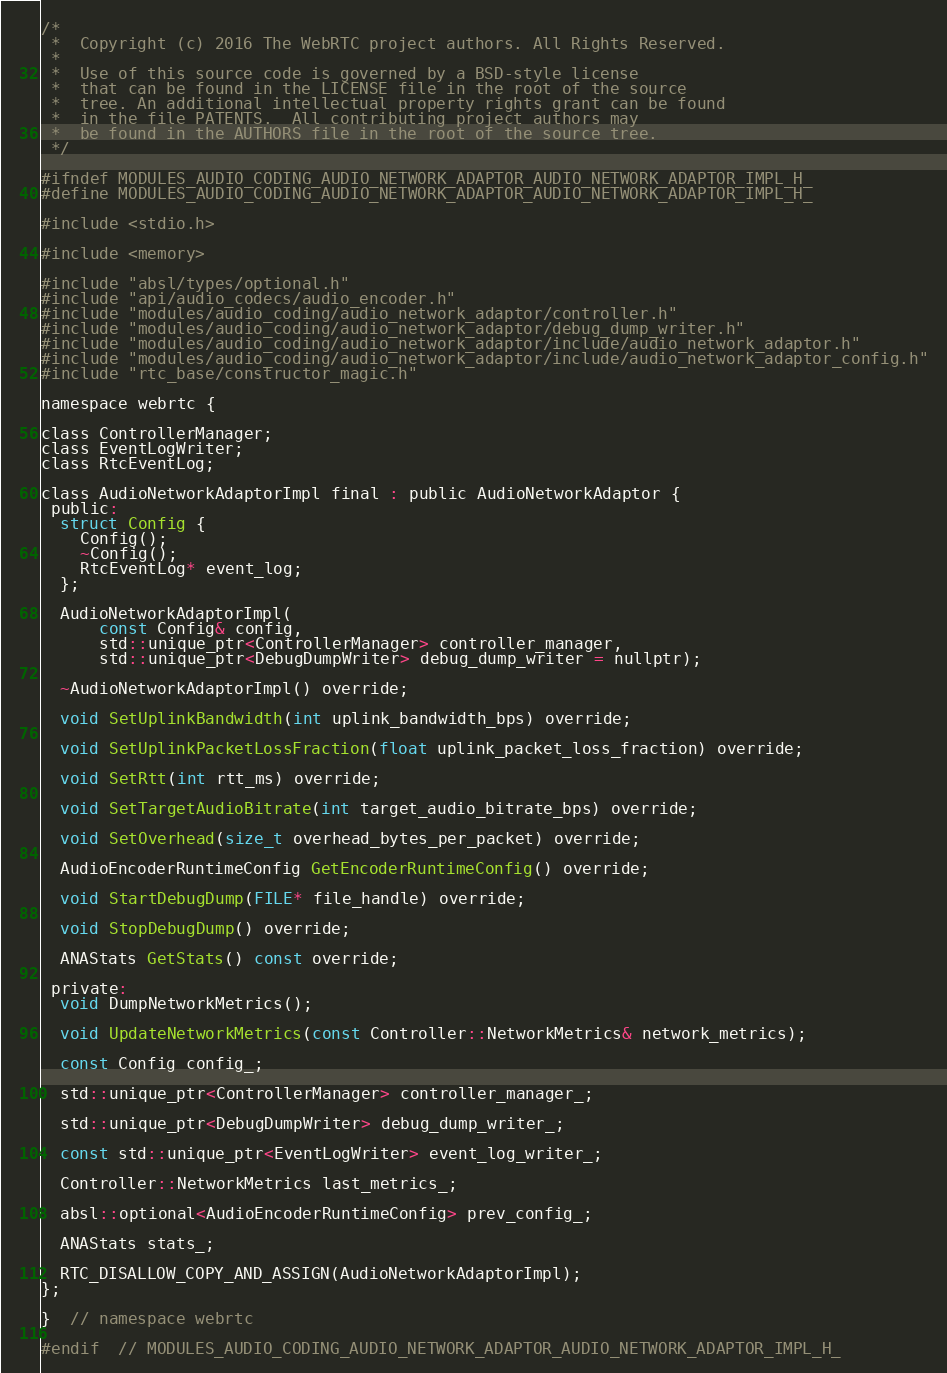<code> <loc_0><loc_0><loc_500><loc_500><_C_>/*
 *  Copyright (c) 2016 The WebRTC project authors. All Rights Reserved.
 *
 *  Use of this source code is governed by a BSD-style license
 *  that can be found in the LICENSE file in the root of the source
 *  tree. An additional intellectual property rights grant can be found
 *  in the file PATENTS.  All contributing project authors may
 *  be found in the AUTHORS file in the root of the source tree.
 */

#ifndef MODULES_AUDIO_CODING_AUDIO_NETWORK_ADAPTOR_AUDIO_NETWORK_ADAPTOR_IMPL_H_
#define MODULES_AUDIO_CODING_AUDIO_NETWORK_ADAPTOR_AUDIO_NETWORK_ADAPTOR_IMPL_H_

#include <stdio.h>

#include <memory>

#include "absl/types/optional.h"
#include "api/audio_codecs/audio_encoder.h"
#include "modules/audio_coding/audio_network_adaptor/controller.h"
#include "modules/audio_coding/audio_network_adaptor/debug_dump_writer.h"
#include "modules/audio_coding/audio_network_adaptor/include/audio_network_adaptor.h"
#include "modules/audio_coding/audio_network_adaptor/include/audio_network_adaptor_config.h"
#include "rtc_base/constructor_magic.h"

namespace webrtc {

class ControllerManager;
class EventLogWriter;
class RtcEventLog;

class AudioNetworkAdaptorImpl final : public AudioNetworkAdaptor {
 public:
  struct Config {
    Config();
    ~Config();
    RtcEventLog* event_log;
  };

  AudioNetworkAdaptorImpl(
      const Config& config,
      std::unique_ptr<ControllerManager> controller_manager,
      std::unique_ptr<DebugDumpWriter> debug_dump_writer = nullptr);

  ~AudioNetworkAdaptorImpl() override;

  void SetUplinkBandwidth(int uplink_bandwidth_bps) override;

  void SetUplinkPacketLossFraction(float uplink_packet_loss_fraction) override;

  void SetRtt(int rtt_ms) override;

  void SetTargetAudioBitrate(int target_audio_bitrate_bps) override;

  void SetOverhead(size_t overhead_bytes_per_packet) override;

  AudioEncoderRuntimeConfig GetEncoderRuntimeConfig() override;

  void StartDebugDump(FILE* file_handle) override;

  void StopDebugDump() override;

  ANAStats GetStats() const override;

 private:
  void DumpNetworkMetrics();

  void UpdateNetworkMetrics(const Controller::NetworkMetrics& network_metrics);

  const Config config_;

  std::unique_ptr<ControllerManager> controller_manager_;

  std::unique_ptr<DebugDumpWriter> debug_dump_writer_;

  const std::unique_ptr<EventLogWriter> event_log_writer_;

  Controller::NetworkMetrics last_metrics_;

  absl::optional<AudioEncoderRuntimeConfig> prev_config_;

  ANAStats stats_;

  RTC_DISALLOW_COPY_AND_ASSIGN(AudioNetworkAdaptorImpl);
};

}  // namespace webrtc

#endif  // MODULES_AUDIO_CODING_AUDIO_NETWORK_ADAPTOR_AUDIO_NETWORK_ADAPTOR_IMPL_H_
</code> 